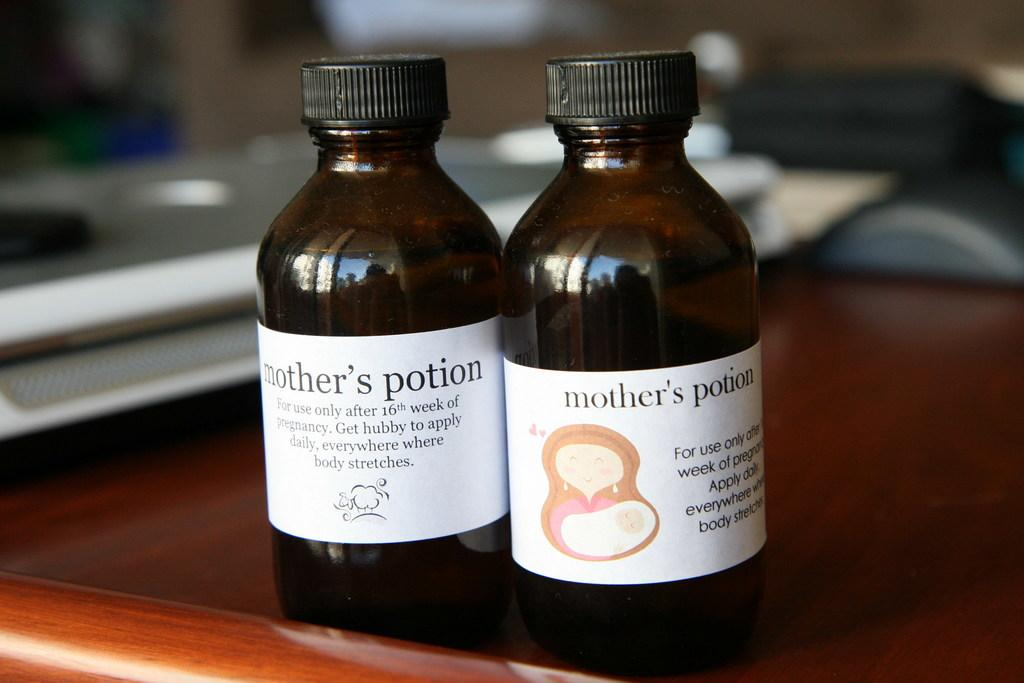<image>
Render a clear and concise summary of the photo. 2 bottles of mother's potion is together on a table. 